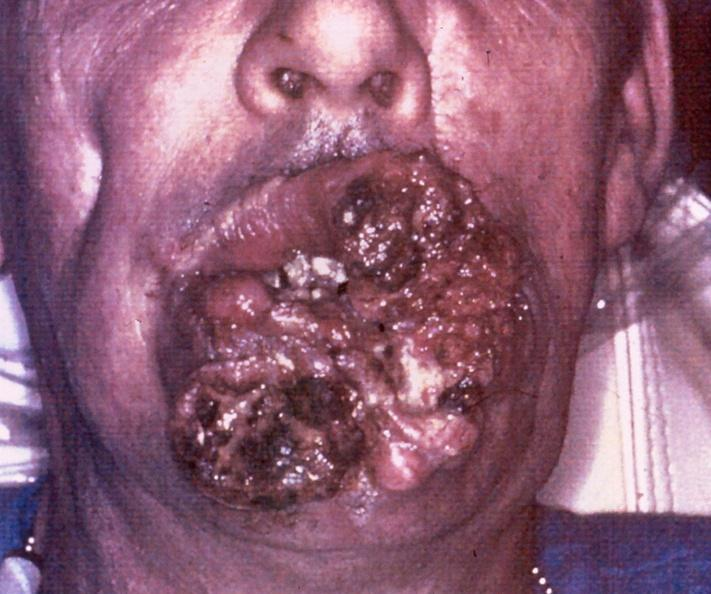what does this image show?
Answer the question using a single word or phrase. Squamous cell carcinoma 